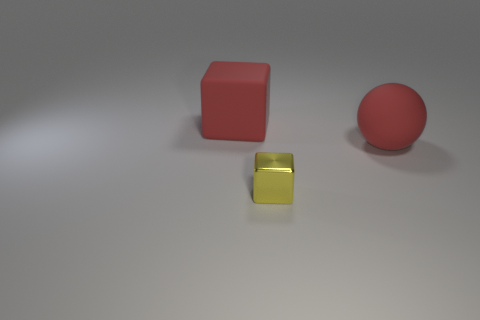Is there any other thing that has the same material as the tiny cube?
Give a very brief answer. No. Are there any other things that are the same size as the metallic block?
Give a very brief answer. No. What number of rubber blocks are to the left of the large red rubber object that is left of the block in front of the large rubber block?
Keep it short and to the point. 0. Is the red thing behind the large red ball made of the same material as the red object that is on the right side of the tiny shiny block?
Make the answer very short. Yes. How many objects are big things that are right of the tiny metallic cube or big red spheres that are on the right side of the metal object?
Provide a succinct answer. 1. Is there anything else that has the same shape as the tiny object?
Give a very brief answer. Yes. What number of red matte objects are there?
Give a very brief answer. 2. Is there a red cylinder of the same size as the red matte ball?
Make the answer very short. No. Does the tiny yellow cube have the same material as the big red thing to the left of the small yellow metallic block?
Your response must be concise. No. What is the material of the cube that is behind the ball?
Your answer should be very brief. Rubber. 